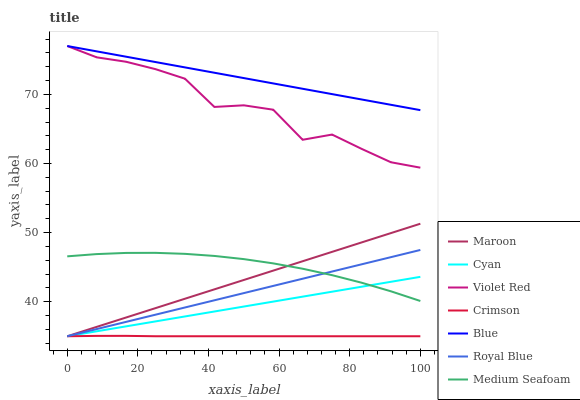Does Crimson have the minimum area under the curve?
Answer yes or no. Yes. Does Blue have the maximum area under the curve?
Answer yes or no. Yes. Does Violet Red have the minimum area under the curve?
Answer yes or no. No. Does Violet Red have the maximum area under the curve?
Answer yes or no. No. Is Cyan the smoothest?
Answer yes or no. Yes. Is Violet Red the roughest?
Answer yes or no. Yes. Is Maroon the smoothest?
Answer yes or no. No. Is Maroon the roughest?
Answer yes or no. No. Does Maroon have the lowest value?
Answer yes or no. Yes. Does Violet Red have the lowest value?
Answer yes or no. No. Does Violet Red have the highest value?
Answer yes or no. Yes. Does Maroon have the highest value?
Answer yes or no. No. Is Crimson less than Medium Seafoam?
Answer yes or no. Yes. Is Violet Red greater than Crimson?
Answer yes or no. Yes. Does Royal Blue intersect Crimson?
Answer yes or no. Yes. Is Royal Blue less than Crimson?
Answer yes or no. No. Is Royal Blue greater than Crimson?
Answer yes or no. No. Does Crimson intersect Medium Seafoam?
Answer yes or no. No. 